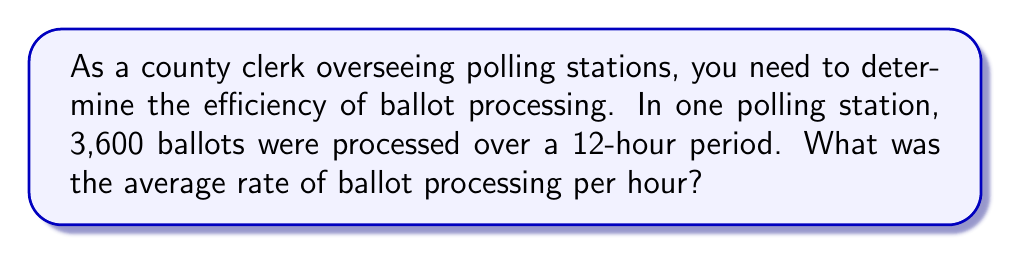Can you solve this math problem? To solve this problem, we need to use the rate formula:

$$\text{Rate} = \frac{\text{Total Quantity}}{\text{Time}}$$

Given:
- Total number of ballots processed: 3,600
- Time period: 12 hours

Let's substitute these values into the formula:

$$\text{Rate} = \frac{3,600 \text{ ballots}}{12 \text{ hours}}$$

Now, we perform the division:

$$\text{Rate} = 300 \text{ ballots per hour}$$

This means that, on average, 300 ballots were processed every hour during the 12-hour period.
Answer: $300 \text{ ballots per hour}$ 